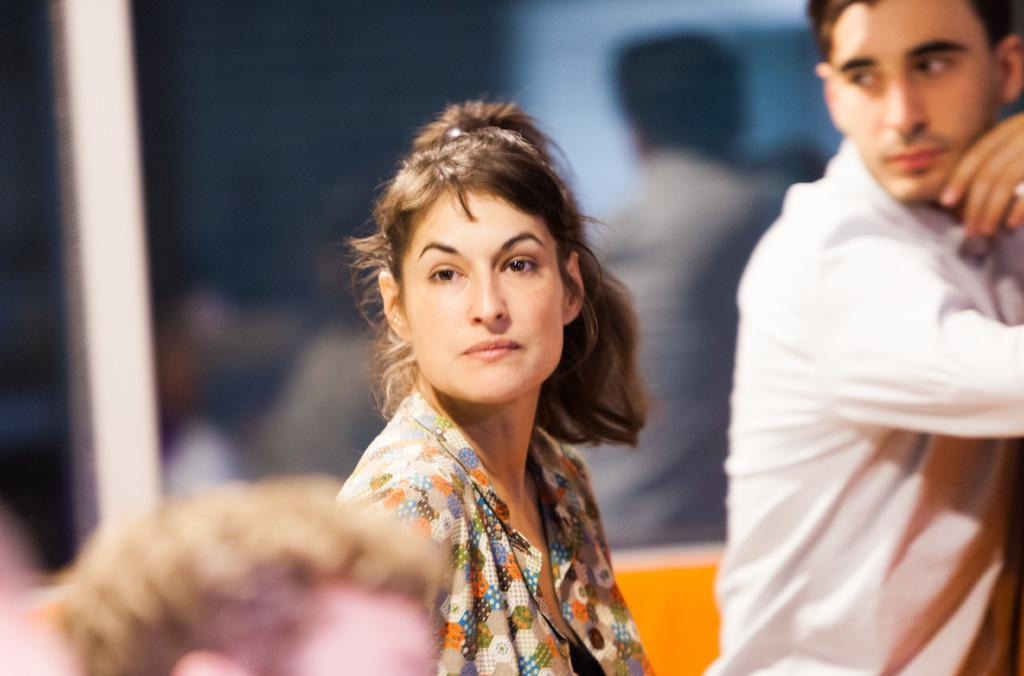Who is the main subject in the image? There is a lady in the center of the image. Can you describe the other person in the image? There is a person to the right side of the image. What can be seen in the background of the image? There is glass visible in the background of the image. What activity is the lady's stomach performing in the image? The lady's stomach is not performing any activity in the image, as it is a part of her body and not an independent entity. 